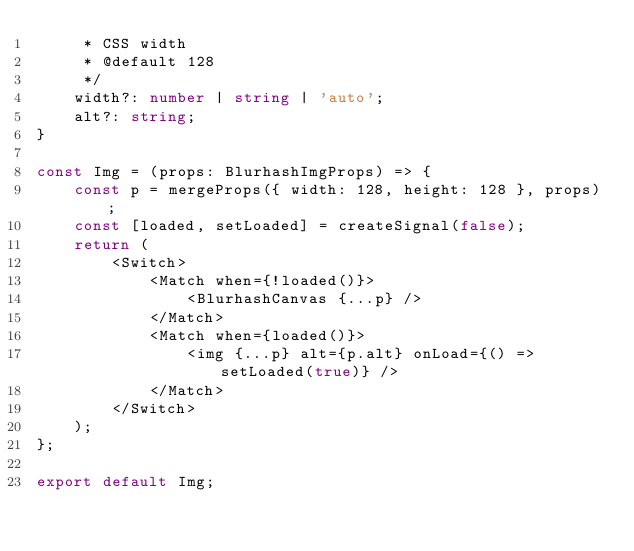Convert code to text. <code><loc_0><loc_0><loc_500><loc_500><_TypeScript_>	 * CSS width
	 * @default 128
	 */
	width?: number | string | 'auto';
	alt?: string;
}

const Img = (props: BlurhashImgProps) => {
	const p = mergeProps({ width: 128, height: 128 }, props);
	const [loaded, setLoaded] = createSignal(false);
	return (
		<Switch>
			<Match when={!loaded()}>
				<BlurhashCanvas {...p} />
			</Match>
			<Match when={loaded()}>
				<img {...p} alt={p.alt} onLoad={() => setLoaded(true)} />
			</Match>
		</Switch>
	);
};

export default Img;
</code> 